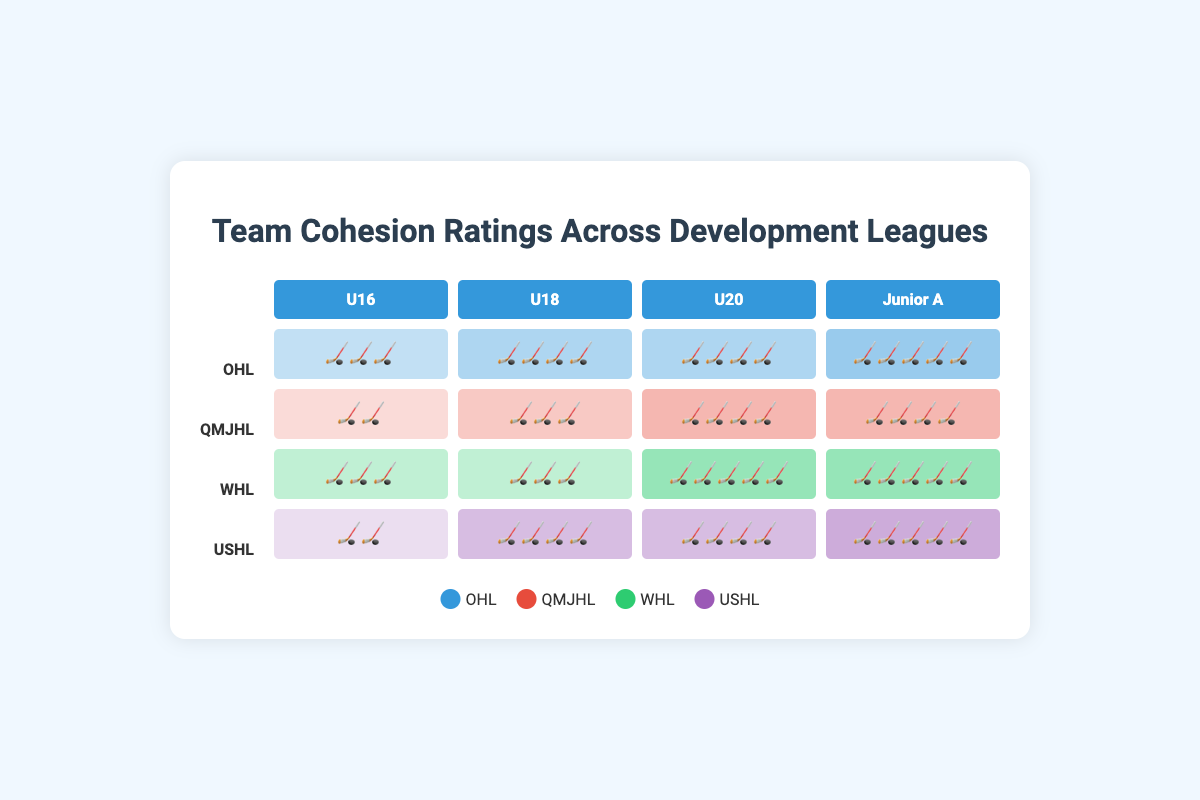Which age group has the highest team cohesion rating in the WHL league? The WHL league's highest rating can be seen by examining the bars corresponding to different age groups. The U20 and Junior A columns both have five sticks, indicating the highest rating.
Answer: U20, Junior A Which league has the highest team cohesion rating at the U16 level? Look at the U16 column and compare the number of sticks for each league. The OHL and WHL both have the maximum rating of three sticks.
Answer: OHL, WHL What is the average team cohesion rating for the USHL league across all age groups? For the USHL league, the ratings are 2 (U16), 4 (U18), 4 (U20), and 5 (Junior A). Calculating the average involves adding these values and dividing by 4: (2+4+4+5)/4 = 3.75.
Answer: 3.75 How does the team cohesion rating of the QMJHL at the Junior A level compare to the OHL at the same level? The QMJHL at the Junior A level has a rating of four sticks while the OHL has a rating of five sticks. Thus, the QCJHL rating is lower by one stick.
Answer: QMJHL is lower by one stick Which age group shows the most consistent team cohesion ratings across all leagues? Consistency can be determined by checking which age group has similar ratings across all leagues. The U20 group has ratings of 4, 4, 5, and 4, showing the least variance.
Answer: U20 What is the sum of the team cohesion ratings for the OHL league? The ratings for the OHL across all age groups are 3 (U16), 4 (U18), 4 (U20), and 5 (Junior A). Adding these together gives 3+4+4+5 = 16.
Answer: 16 If you wanted to identify the league with the lowest team cohesion at the U18 level, which one would it be? At the U18 level, comparing the number of sticks for each league, the QMJHL has the least number with three sticks.
Answer: QMJHL Which league shows the highest incremental improvement in team cohesion ratings from U16 to U20? To find the highest incremental improvement, calculate the difference between U16 and U20 for each league: OHL: 4-3 = 1, QMJHL: 4-2 = 2, WHL: 5-3 = 2, USHL: 4-2 = 2. Thus, QMJHL, WHL, and USHL all have the highest incremental improvement of 2.
Answer: QMJHL, WHL, USHL Please list the leagues in descending order of their team cohesion ratings at the U20 level? Looking at the U20 level, the ratings in descending order are: WHL (5), OHL (4), QMJHL (4), USHL (4). Since OHL, QMJHL, and USHL have equal ratings, they can be listed in any order after WHL.
Answer: WHL, OHL/QMJHL/USHL 